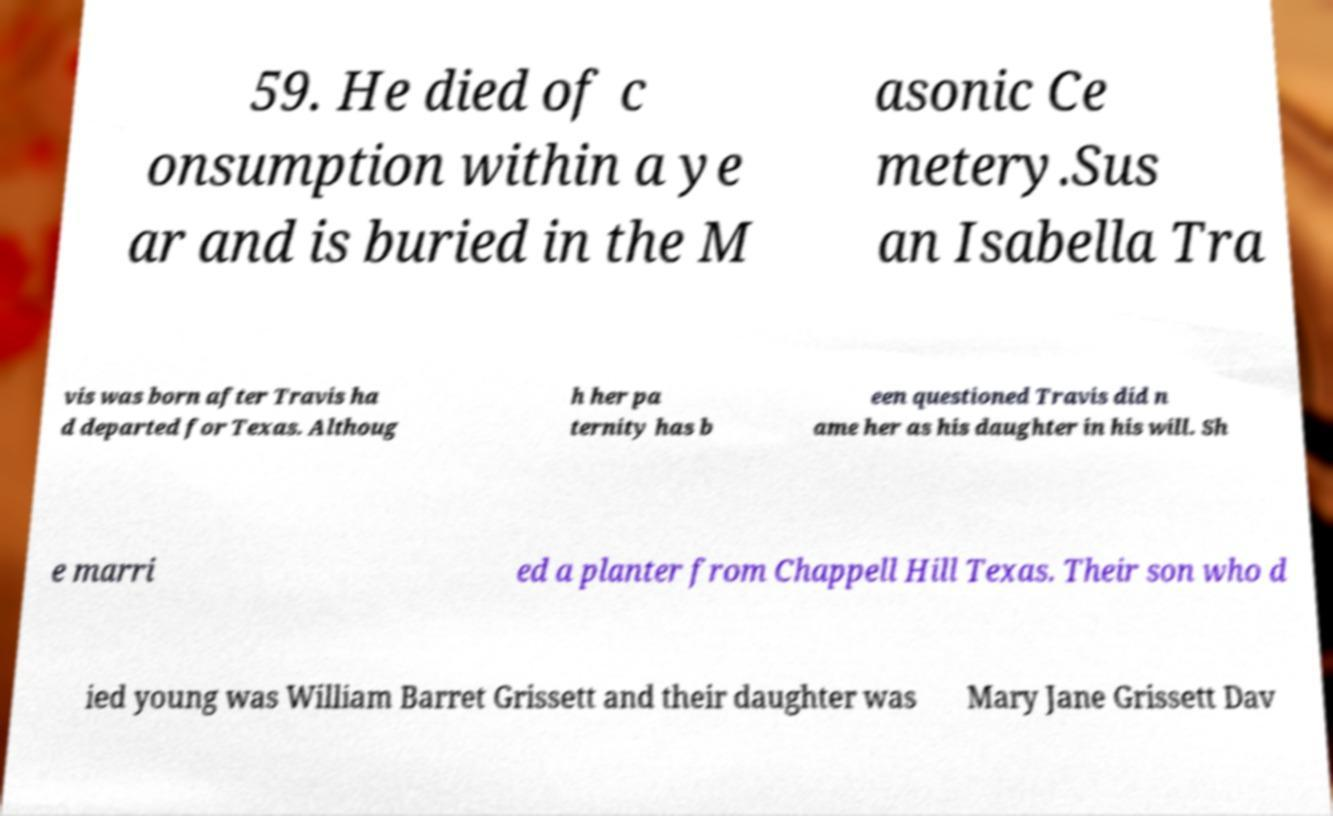Could you assist in decoding the text presented in this image and type it out clearly? 59. He died of c onsumption within a ye ar and is buried in the M asonic Ce metery.Sus an Isabella Tra vis was born after Travis ha d departed for Texas. Althoug h her pa ternity has b een questioned Travis did n ame her as his daughter in his will. Sh e marri ed a planter from Chappell Hill Texas. Their son who d ied young was William Barret Grissett and their daughter was Mary Jane Grissett Dav 